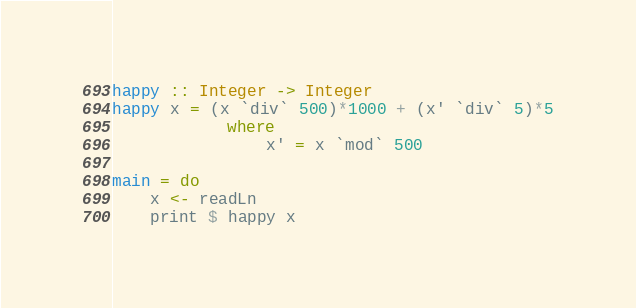Convert code to text. <code><loc_0><loc_0><loc_500><loc_500><_Haskell_>happy :: Integer -> Integer
happy x = (x `div` 500)*1000 + (x' `div` 5)*5
            where
                x' = x `mod` 500

main = do
    x <- readLn
    print $ happy x</code> 